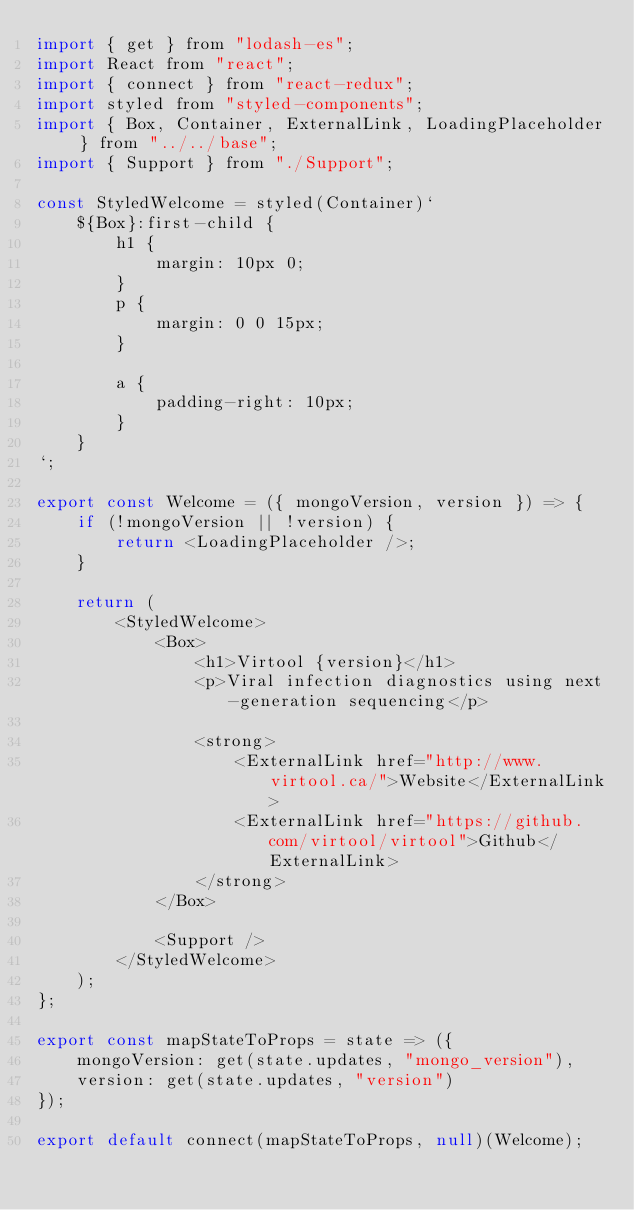<code> <loc_0><loc_0><loc_500><loc_500><_JavaScript_>import { get } from "lodash-es";
import React from "react";
import { connect } from "react-redux";
import styled from "styled-components";
import { Box, Container, ExternalLink, LoadingPlaceholder } from "../../base";
import { Support } from "./Support";

const StyledWelcome = styled(Container)`
    ${Box}:first-child {
        h1 {
            margin: 10px 0;
        }
        p {
            margin: 0 0 15px;
        }

        a {
            padding-right: 10px;
        }
    }
`;

export const Welcome = ({ mongoVersion, version }) => {
    if (!mongoVersion || !version) {
        return <LoadingPlaceholder />;
    }

    return (
        <StyledWelcome>
            <Box>
                <h1>Virtool {version}</h1>
                <p>Viral infection diagnostics using next-generation sequencing</p>

                <strong>
                    <ExternalLink href="http://www.virtool.ca/">Website</ExternalLink>
                    <ExternalLink href="https://github.com/virtool/virtool">Github</ExternalLink>
                </strong>
            </Box>

            <Support />
        </StyledWelcome>
    );
};

export const mapStateToProps = state => ({
    mongoVersion: get(state.updates, "mongo_version"),
    version: get(state.updates, "version")
});

export default connect(mapStateToProps, null)(Welcome);
</code> 